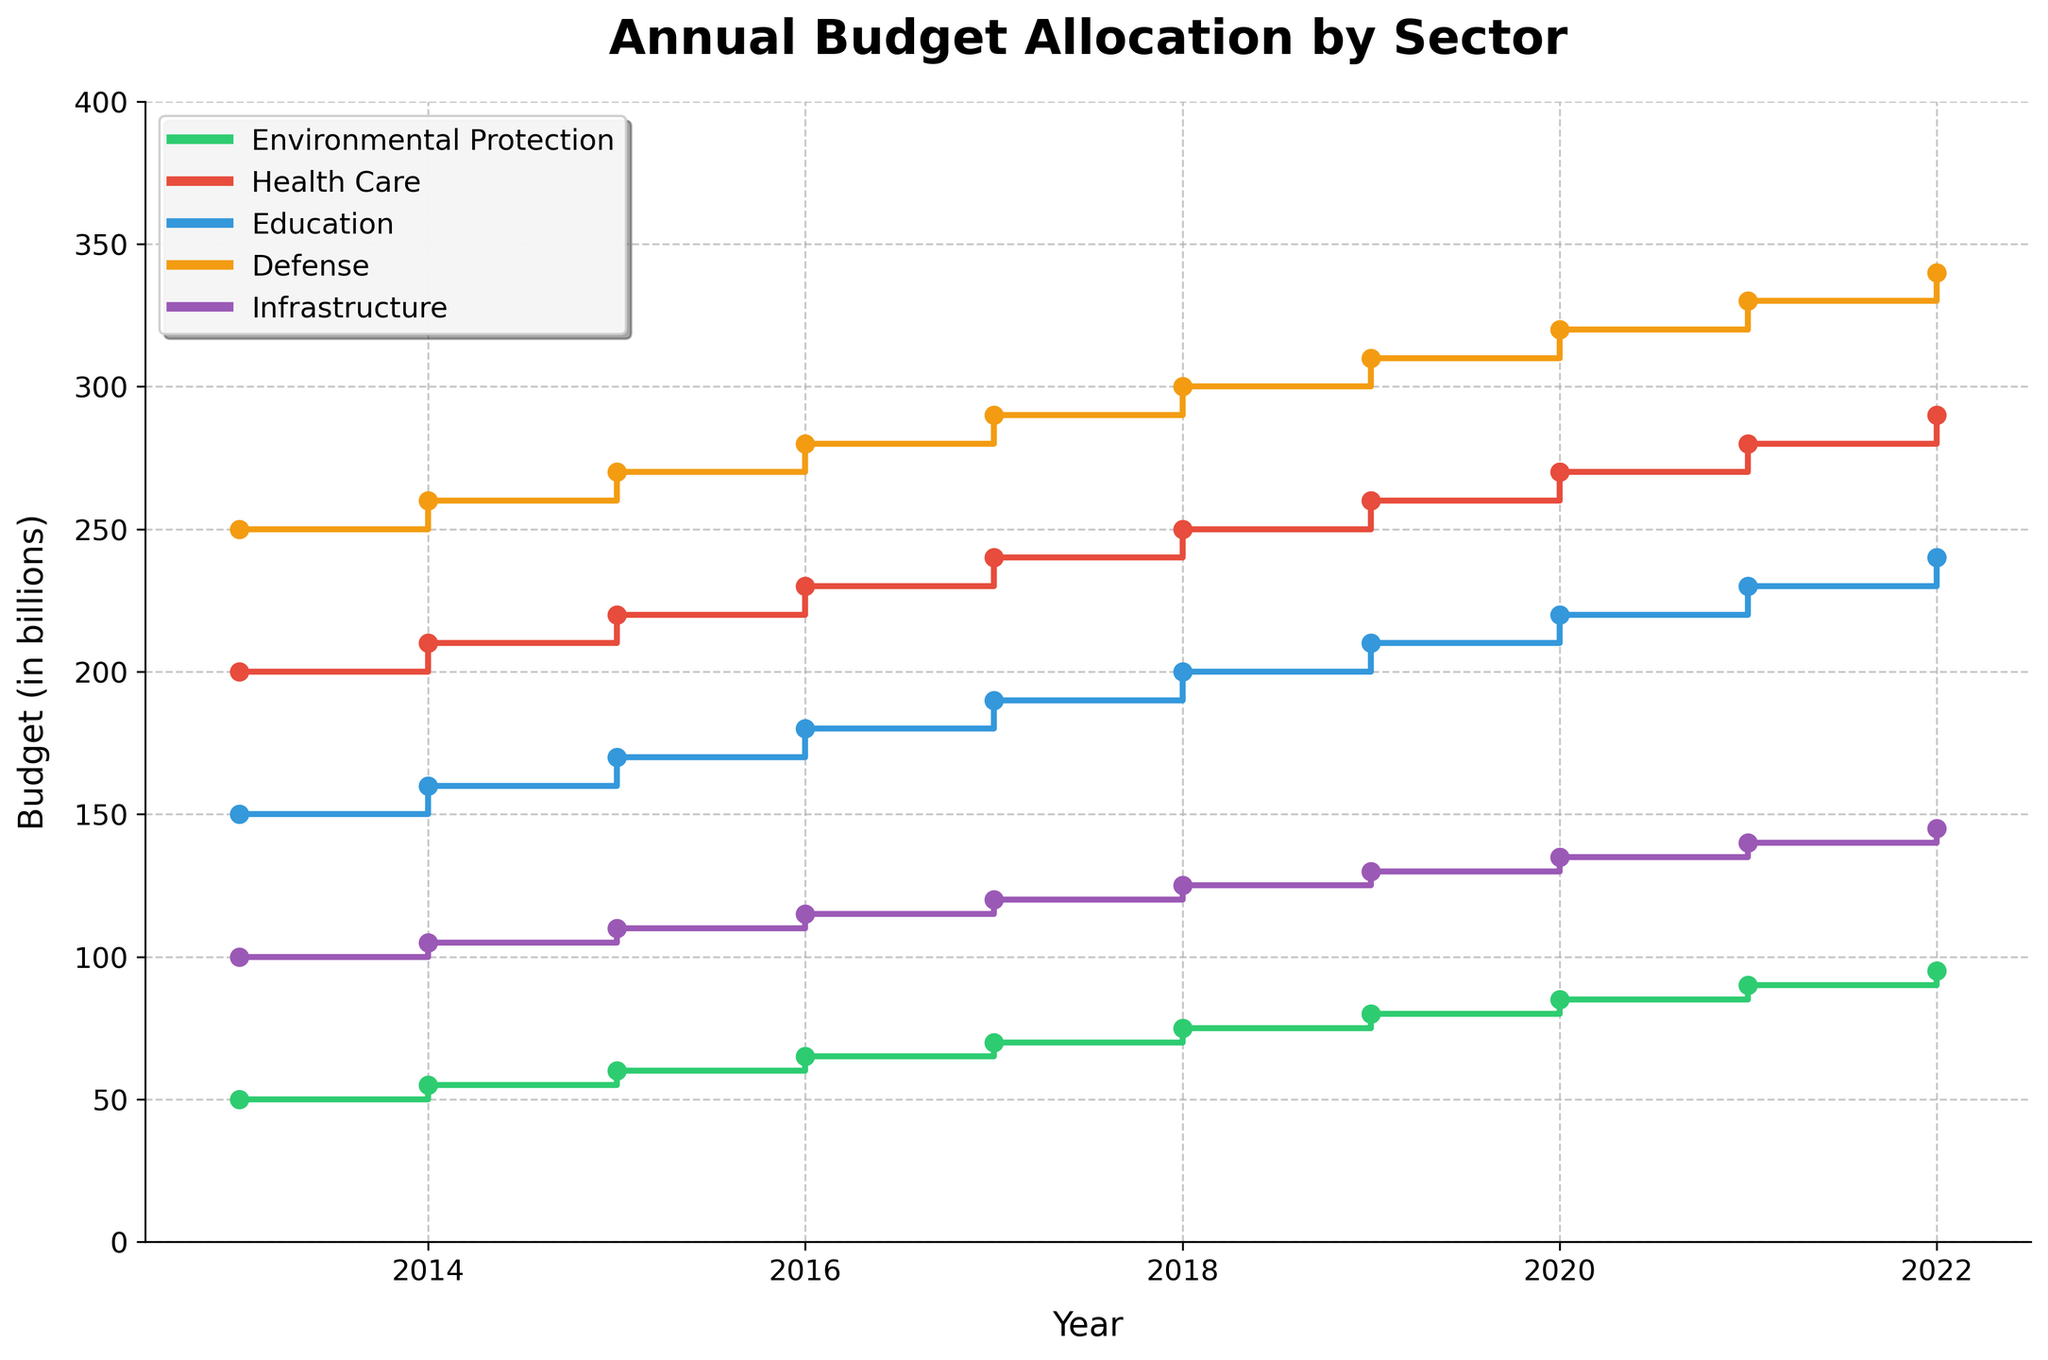What is the title of the figure? The title of the figure is prominently displayed at the top. It is in larger, bold font to catch the viewer's attention.
Answer: Annual Budget Allocation by Sector Which sector had the highest budget allocation in 2015? To find the highest budget allocation in 2015, check the values corresponding to 2015 for each sector. The highest value is from the Defense sector with a budget of 270 billion.
Answer: Defense How much more was allocated to Defense than to Environmental Protection in 2022? To find the difference, subtract the budget for Environmental Protection (95 billion) from the budget for Defense (340 billion) in 2022. 340 - 95 = 245 billion.
Answer: 245 billion What is the overall trend for Environmental Protection expenditure over the years? By observing the stair step line for Environmental Protection, it can be seen that the budget allocation has steadily increased each year from 50 billion in 2013 to 95 billion in 2022.
Answer: Increased steadily In which year was the budget for Infrastructure first greater than 120 billion? Locate the stair step for Infrastructure and track the values year by year. The budget surpasses 120 billion in 2018, where it is 125 billion.
Answer: 2018 Between Health Care and Education, which sector had a higher budget allocation in 2020 and by how much? Check the values for both sectors in 2020. Health Care had 270 billion, while Education had 220 billion. The difference is 270 - 220 = 50 billion.
Answer: Health Care, by 50 billion What is the average annual budget for Health Care over the decade shown in the plot? Sum the yearly budgets for Health Care (200+210+220+230+240+250+260+270+280+290=2450 billion) and divide by the number of years (10). 2450 / 10 = 245 billion.
Answer: 245 billion By what percentage did the budget for Education increase from 2014 to 2019? Calculate the increase from 160 billion in 2014 to 210 billion in 2019, which is 50 billion. The percentage increase is (50/160) * 100 ≈ 31.25%.
Answer: 31.25% Which year had the lowest budget allocation for Environmental Protection, and what was it? The lowest budget for Environmental Protection was in 2013, with an allocation of 50 billion.
Answer: 2013, 50 billion Do any two sectors have the same budget allocation in any given year? If so, which sector and when? Check the values for overlap across all sectors year by year. In 2021, Environmental Protection and Infrastructure both had a budget of 140 billion.
Answer: Environmental Protection and Infrastructure, 2021 